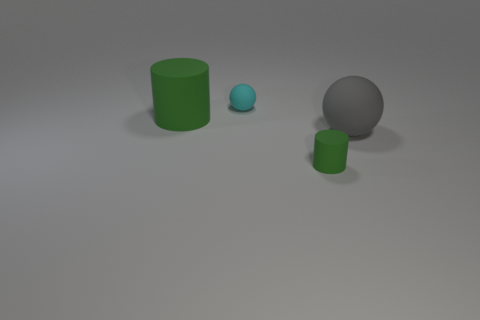Does the big cylinder have the same color as the matte sphere that is behind the big green thing?
Your answer should be very brief. No. There is a green rubber cylinder in front of the sphere in front of the large green object; are there any big matte spheres that are to the left of it?
Provide a succinct answer. No. Is the number of gray rubber spheres on the left side of the cyan matte object less than the number of small red cylinders?
Provide a short and direct response. No. How many objects are either spheres that are right of the tiny cyan thing or green rubber cylinders that are in front of the big matte ball?
Make the answer very short. 2. What is the size of the thing that is in front of the large green matte object and behind the tiny green cylinder?
Your answer should be compact. Large. Do the large thing on the right side of the tiny cyan rubber object and the large green matte thing have the same shape?
Provide a succinct answer. No. There is a object left of the small rubber thing that is behind the green matte cylinder that is on the left side of the cyan rubber thing; what is its size?
Ensure brevity in your answer.  Large. There is a thing that is the same color as the big cylinder; what is its size?
Provide a short and direct response. Small. How many things are big yellow metal things or tiny rubber objects?
Give a very brief answer. 2. There is a thing that is on the left side of the small matte cylinder and in front of the small rubber sphere; what is its shape?
Give a very brief answer. Cylinder. 